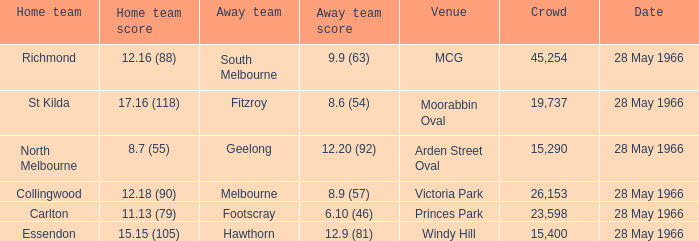Which Venue has a Home team of essendon? Windy Hill. 